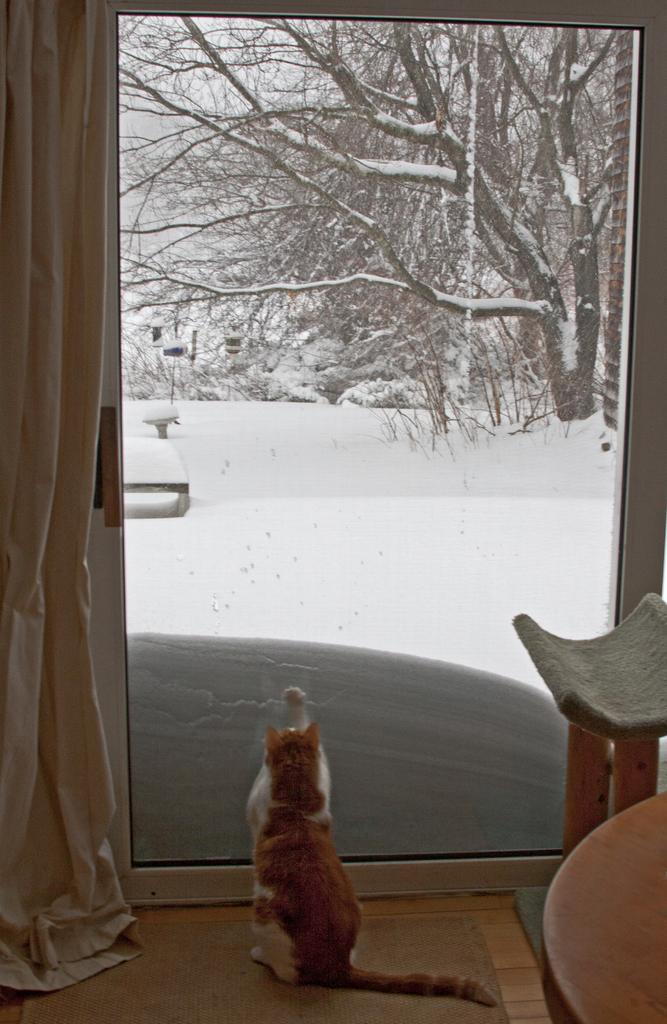What is the main subject in the middle of the image? There is a cat in the middle of the image. What can be seen inside the room in the image? There is a window visible inside the room. What is the weather like outside the window? Outside the window, there is snow visible, which suggests a cold and wintry scene. What else can be seen outside the window? There is a tree visible outside the window. What type of brass instrument is the cat playing in the image? There is no brass instrument present in the image; the cat is not playing any musical instrument. 